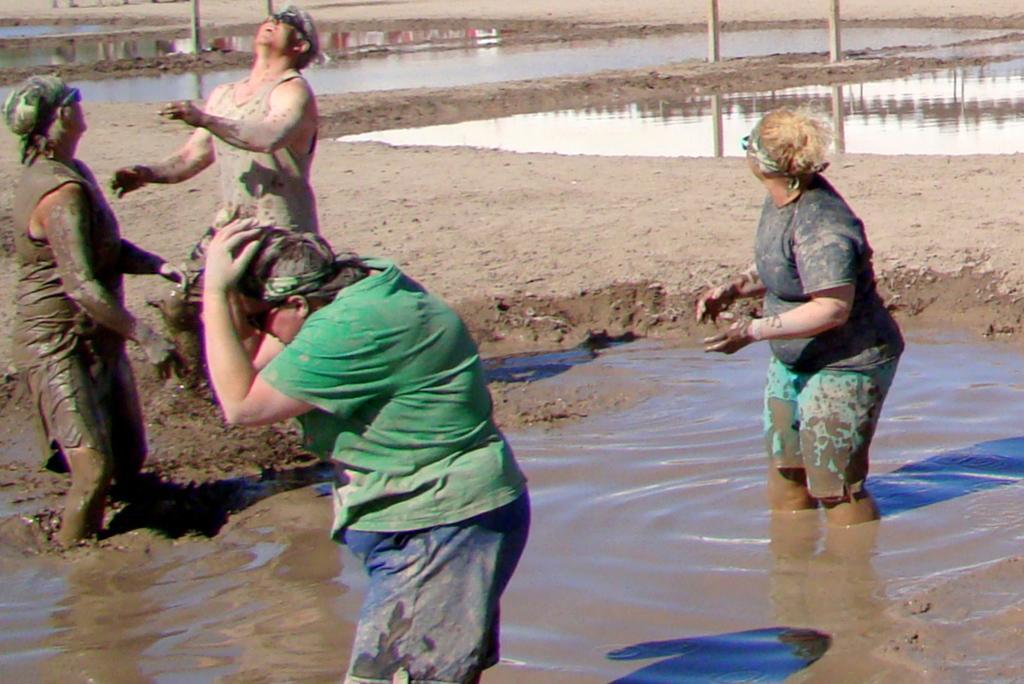Please provide a concise description of this image. In this picture I can observe four members. Two of them are in the water and two of them are standing on the mud. In the background I can observe some poles and water. 